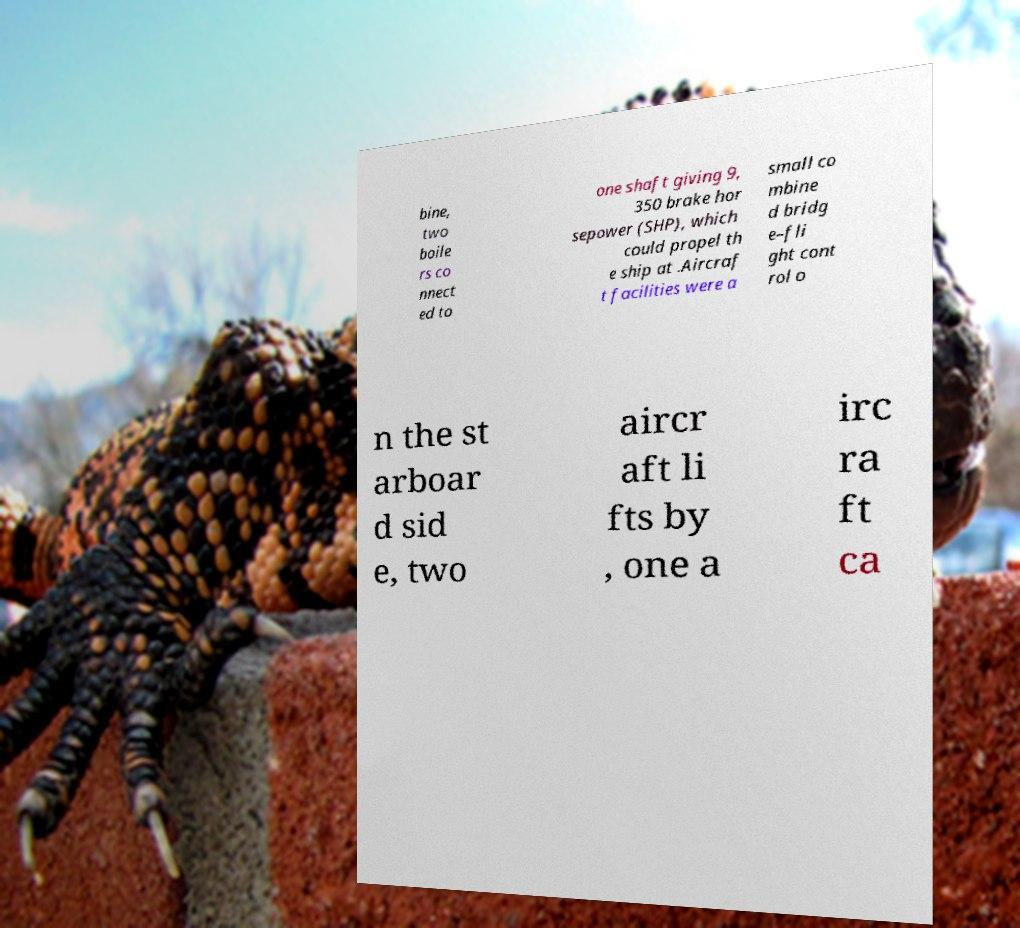Please read and relay the text visible in this image. What does it say? bine, two boile rs co nnect ed to one shaft giving 9, 350 brake hor sepower (SHP), which could propel th e ship at .Aircraf t facilities were a small co mbine d bridg e–fli ght cont rol o n the st arboar d sid e, two aircr aft li fts by , one a irc ra ft ca 